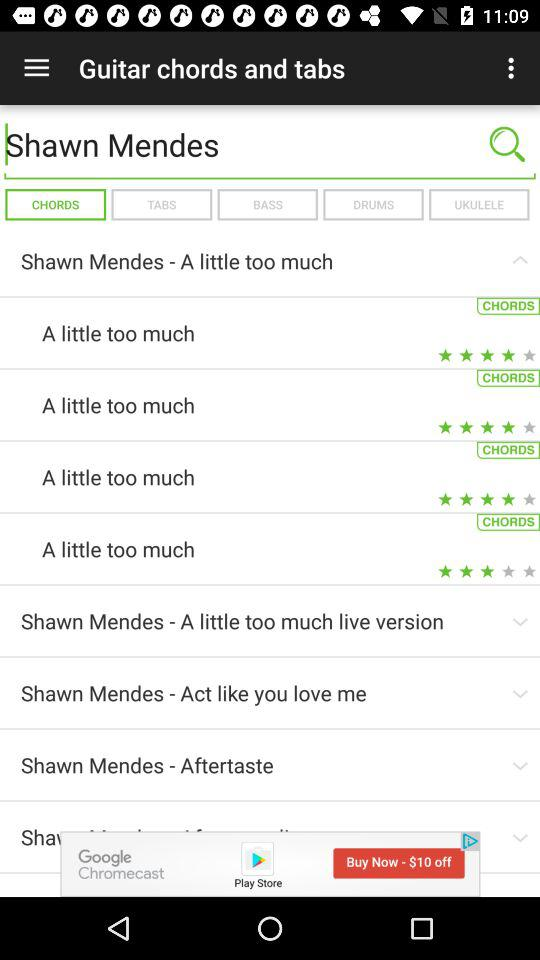What is the entered name? The entered name is "Shawn Mendes". 